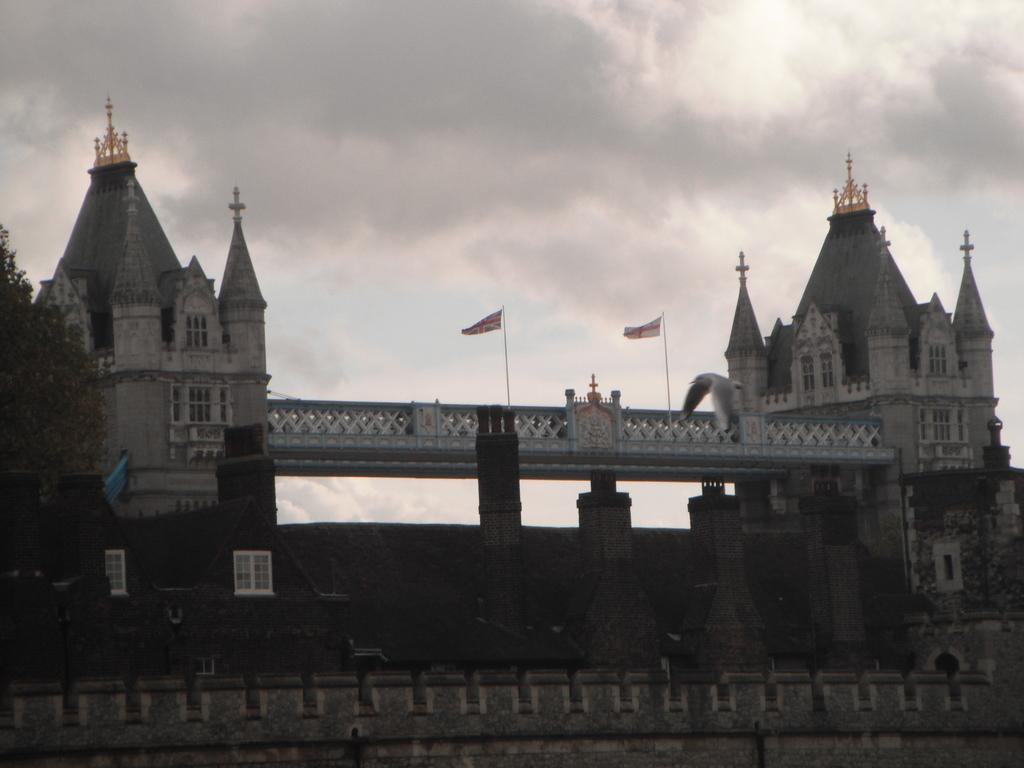What type of structure is in the image? There is a bridge in the image. What else can be seen in the image besides the bridge? There are buildings, pillars, trees, flags, and the sky visible in the image. Can you describe the weather conditions be inferred from the image? Yes, clouds are present in the sky, which suggests that the weather might be partly cloudy. How many flags are visible in the image? Flags are in the image, but the exact number cannot be determined from the provided facts. How many spiders are crawling on the boot in the image? There is no boot or spiders present in the image. 